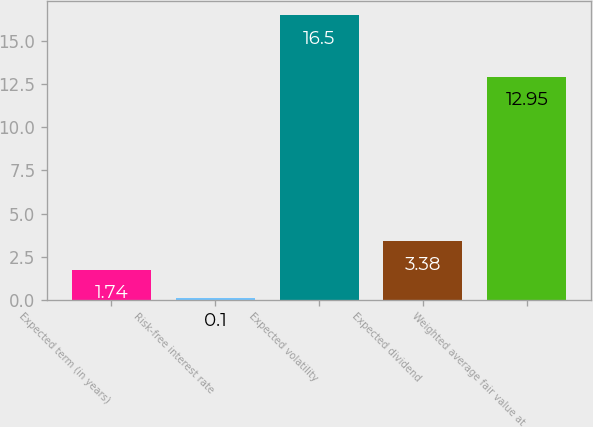Convert chart. <chart><loc_0><loc_0><loc_500><loc_500><bar_chart><fcel>Expected term (in years)<fcel>Risk-free interest rate<fcel>Expected volatility<fcel>Expected dividend<fcel>Weighted average fair value at<nl><fcel>1.74<fcel>0.1<fcel>16.5<fcel>3.38<fcel>12.95<nl></chart> 